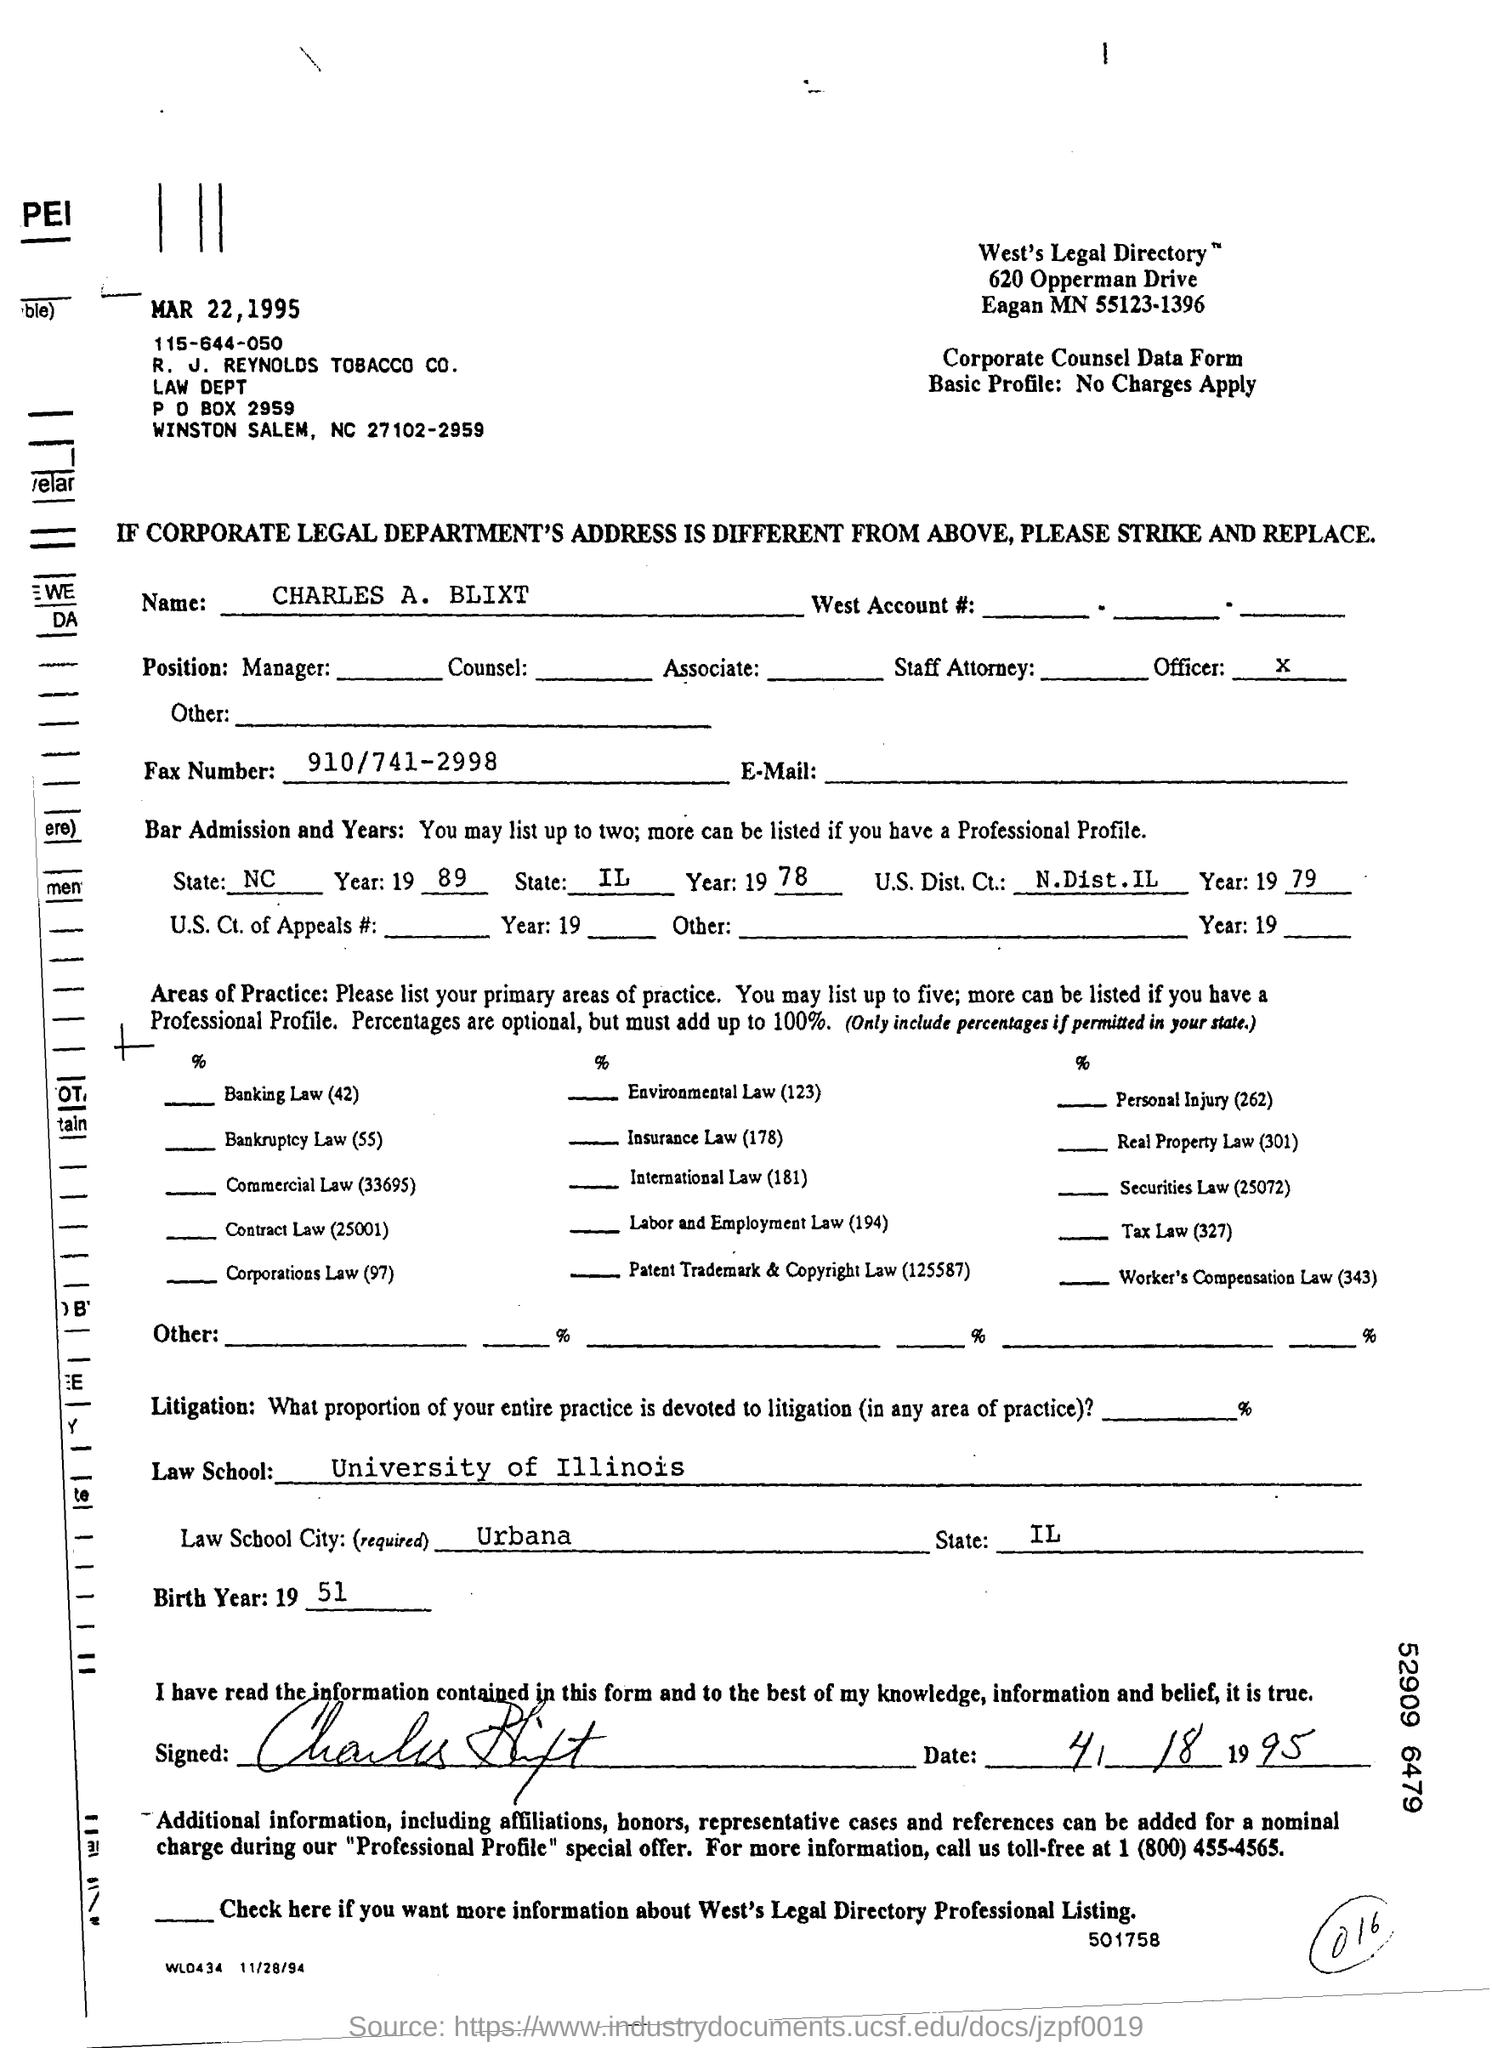What is the P O BOX Number ?
Offer a terse response. P O BOX 2959. What is the date mentioned in the top of the document ?
Ensure brevity in your answer.  MAR 22, 1995. What is the Fax Number ?
Your response must be concise. 910/741-2998. What is mentioned in the Birth Year Field ?
Your response must be concise. 51. What is the City name of Law School ?
Provide a short and direct response. Urbana. What is written in the Officer Field ?
Offer a terse response. X. 